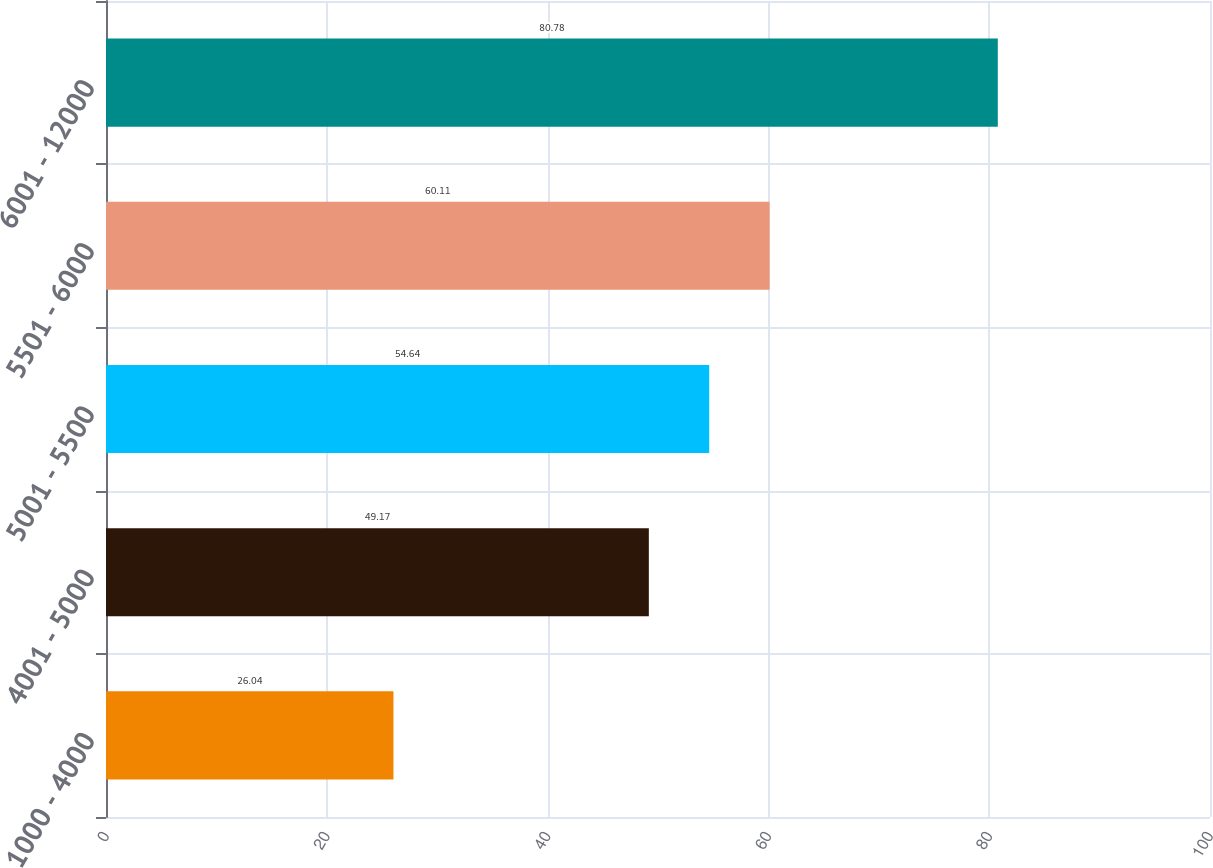<chart> <loc_0><loc_0><loc_500><loc_500><bar_chart><fcel>1000 - 4000<fcel>4001 - 5000<fcel>5001 - 5500<fcel>5501 - 6000<fcel>6001 - 12000<nl><fcel>26.04<fcel>49.17<fcel>54.64<fcel>60.11<fcel>80.78<nl></chart> 